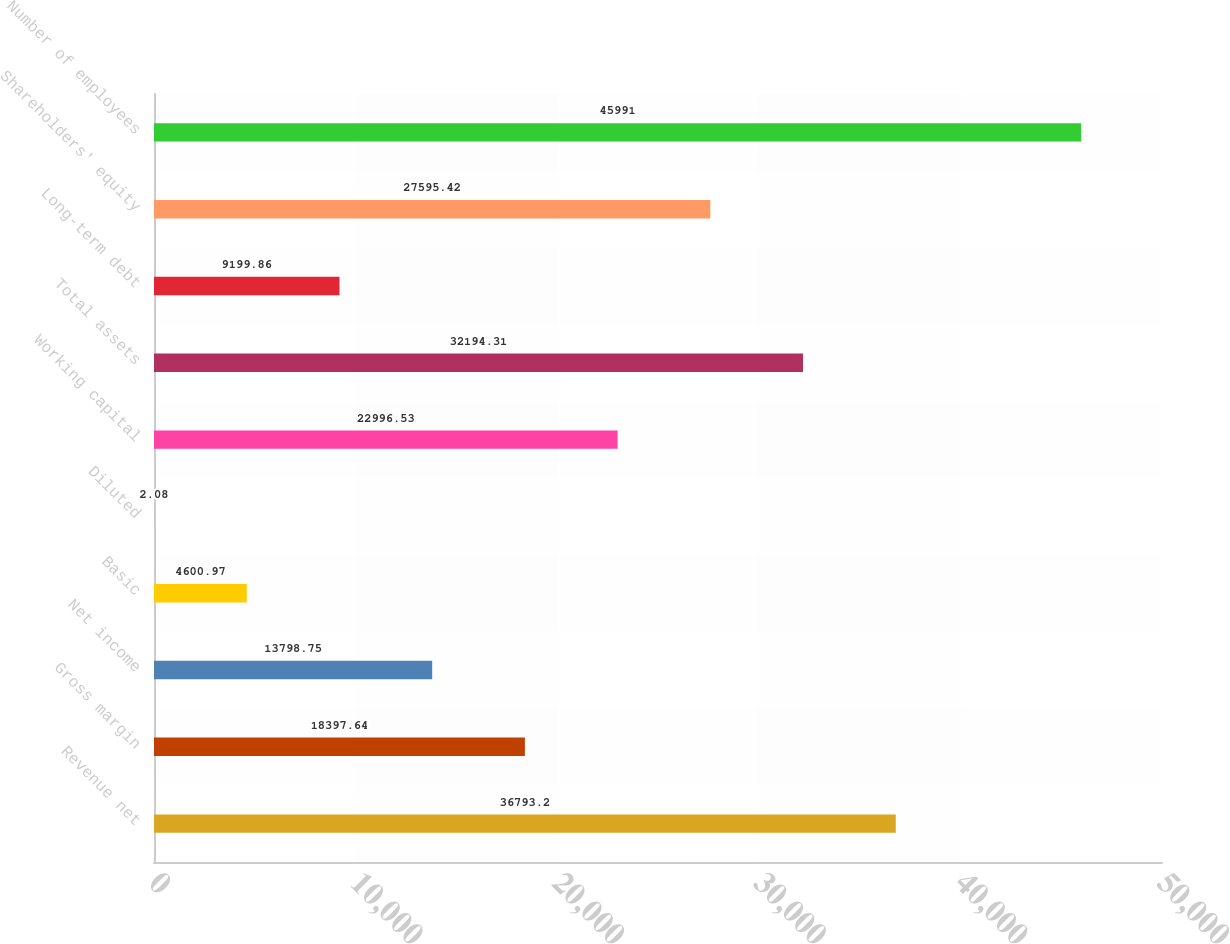<chart> <loc_0><loc_0><loc_500><loc_500><bar_chart><fcel>Revenue net<fcel>Gross margin<fcel>Net income<fcel>Basic<fcel>Diluted<fcel>Working capital<fcel>Total assets<fcel>Long-term debt<fcel>Shareholders' equity<fcel>Number of employees<nl><fcel>36793.2<fcel>18397.6<fcel>13798.8<fcel>4600.97<fcel>2.08<fcel>22996.5<fcel>32194.3<fcel>9199.86<fcel>27595.4<fcel>45991<nl></chart> 